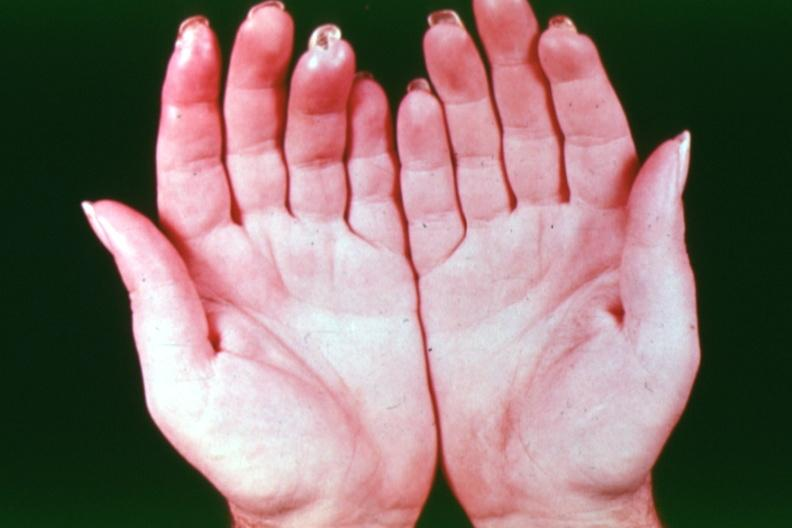s hand present?
Answer the question using a single word or phrase. Yes 